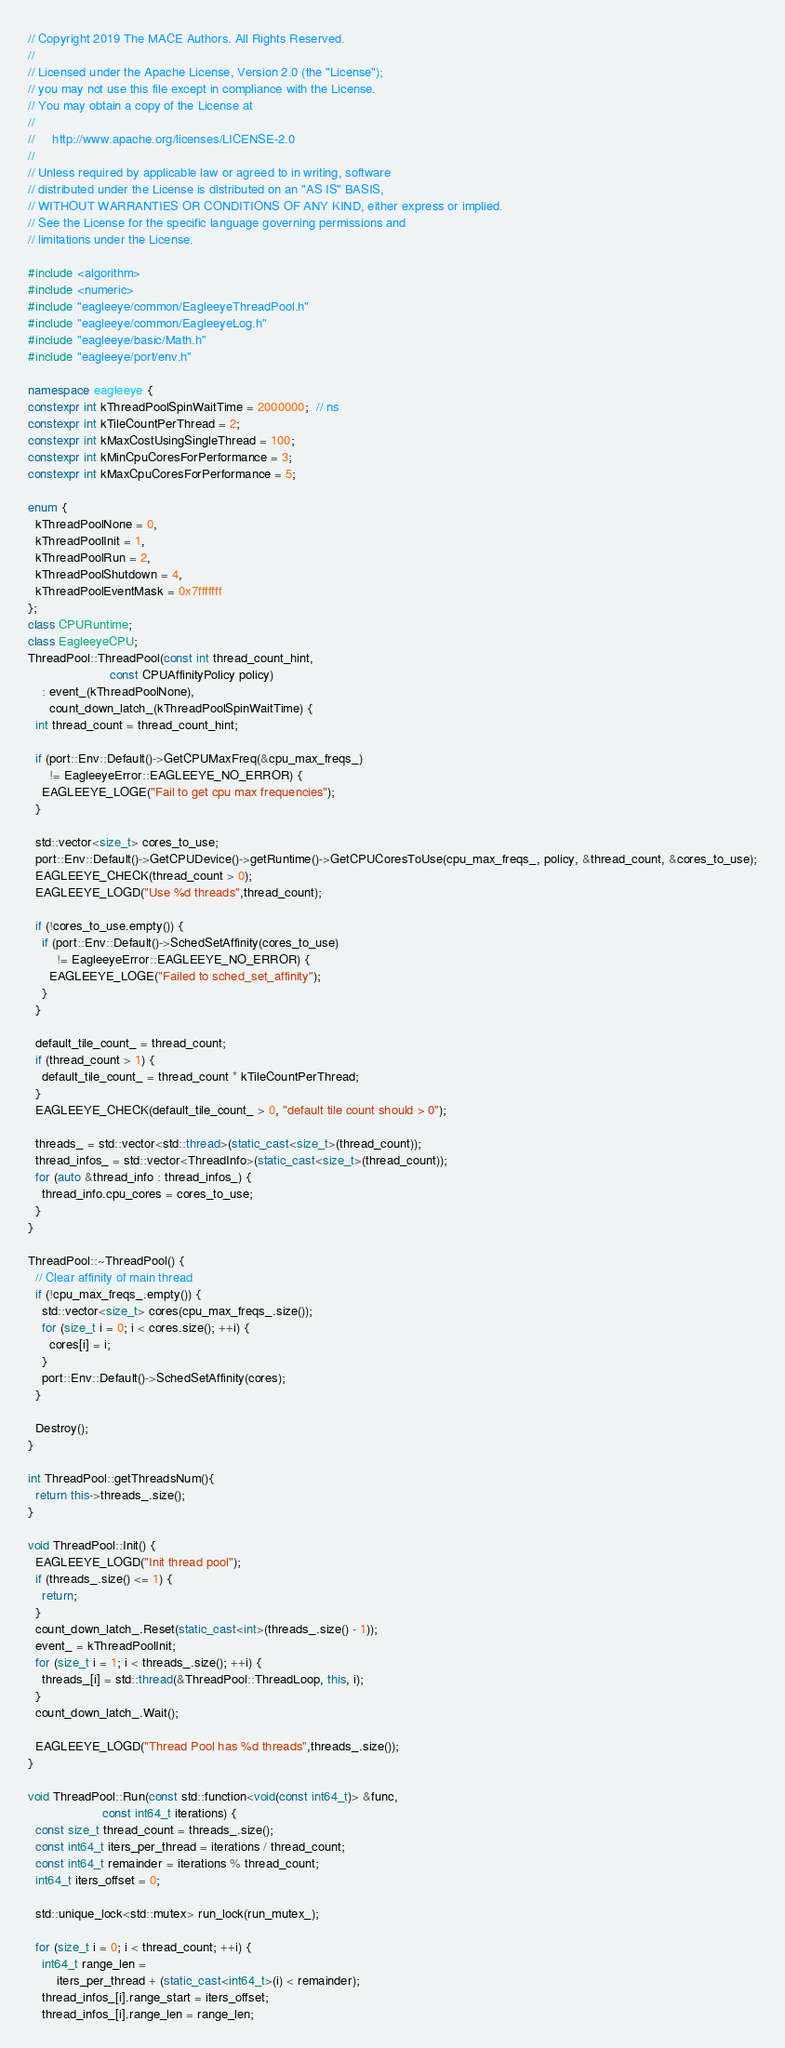<code> <loc_0><loc_0><loc_500><loc_500><_C++_>// Copyright 2019 The MACE Authors. All Rights Reserved.
//
// Licensed under the Apache License, Version 2.0 (the "License");
// you may not use this file except in compliance with the License.
// You may obtain a copy of the License at
//
//     http://www.apache.org/licenses/LICENSE-2.0
//
// Unless required by applicable law or agreed to in writing, software
// distributed under the License is distributed on an "AS IS" BASIS,
// WITHOUT WARRANTIES OR CONDITIONS OF ANY KIND, either express or implied.
// See the License for the specific language governing permissions and
// limitations under the License.

#include <algorithm>
#include <numeric>
#include "eagleeye/common/EagleeyeThreadPool.h"
#include "eagleeye/common/EagleeyeLog.h"
#include "eagleeye/basic/Math.h"
#include "eagleeye/port/env.h"

namespace eagleeye {
constexpr int kThreadPoolSpinWaitTime = 2000000;  // ns
constexpr int kTileCountPerThread = 2;
constexpr int kMaxCostUsingSingleThread = 100;
constexpr int kMinCpuCoresForPerformance = 3;
constexpr int kMaxCpuCoresForPerformance = 5;

enum {
  kThreadPoolNone = 0,
  kThreadPoolInit = 1,
  kThreadPoolRun = 2,
  kThreadPoolShutdown = 4,
  kThreadPoolEventMask = 0x7fffffff
};
class CPURuntime;
class EagleeyeCPU;
ThreadPool::ThreadPool(const int thread_count_hint,
                       const CPUAffinityPolicy policy)
    : event_(kThreadPoolNone),
      count_down_latch_(kThreadPoolSpinWaitTime) {
  int thread_count = thread_count_hint;

  if (port::Env::Default()->GetCPUMaxFreq(&cpu_max_freqs_)
      != EagleeyeError::EAGLEEYE_NO_ERROR) {
    EAGLEEYE_LOGE("Fail to get cpu max frequencies");
  }

  std::vector<size_t> cores_to_use;
  port::Env::Default()->GetCPUDevice()->getRuntime()->GetCPUCoresToUse(cpu_max_freqs_, policy, &thread_count, &cores_to_use);
  EAGLEEYE_CHECK(thread_count > 0);
  EAGLEEYE_LOGD("Use %d threads",thread_count);

  if (!cores_to_use.empty()) {
    if (port::Env::Default()->SchedSetAffinity(cores_to_use)
        != EagleeyeError::EAGLEEYE_NO_ERROR) {
      EAGLEEYE_LOGE("Failed to sched_set_affinity");
    }
  }

  default_tile_count_ = thread_count;
  if (thread_count > 1) {
    default_tile_count_ = thread_count * kTileCountPerThread;
  }
  EAGLEEYE_CHECK(default_tile_count_ > 0, "default tile count should > 0");

  threads_ = std::vector<std::thread>(static_cast<size_t>(thread_count));
  thread_infos_ = std::vector<ThreadInfo>(static_cast<size_t>(thread_count));
  for (auto &thread_info : thread_infos_) {
    thread_info.cpu_cores = cores_to_use;
  }
}

ThreadPool::~ThreadPool() {
  // Clear affinity of main thread
  if (!cpu_max_freqs_.empty()) {
    std::vector<size_t> cores(cpu_max_freqs_.size());
    for (size_t i = 0; i < cores.size(); ++i) {
      cores[i] = i;
    }
    port::Env::Default()->SchedSetAffinity(cores);
  }

  Destroy();
}

int ThreadPool::getThreadsNum(){
  return this->threads_.size();
}

void ThreadPool::Init() {
  EAGLEEYE_LOGD("Init thread pool");
  if (threads_.size() <= 1) {
    return;
  }
  count_down_latch_.Reset(static_cast<int>(threads_.size() - 1));
  event_ = kThreadPoolInit;
  for (size_t i = 1; i < threads_.size(); ++i) {
    threads_[i] = std::thread(&ThreadPool::ThreadLoop, this, i);
  }
  count_down_latch_.Wait();

  EAGLEEYE_LOGD("Thread Pool has %d threads",threads_.size());
}

void ThreadPool::Run(const std::function<void(const int64_t)> &func,
                     const int64_t iterations) {
  const size_t thread_count = threads_.size();
  const int64_t iters_per_thread = iterations / thread_count;
  const int64_t remainder = iterations % thread_count;
  int64_t iters_offset = 0;

  std::unique_lock<std::mutex> run_lock(run_mutex_);

  for (size_t i = 0; i < thread_count; ++i) {
    int64_t range_len =
        iters_per_thread + (static_cast<int64_t>(i) < remainder);
    thread_infos_[i].range_start = iters_offset;
    thread_infos_[i].range_len = range_len;</code> 